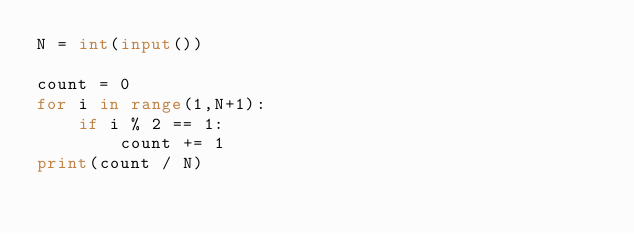Convert code to text. <code><loc_0><loc_0><loc_500><loc_500><_Python_>N = int(input())

count = 0
for i in range(1,N+1):
    if i % 2 == 1:
        count += 1
print(count / N)</code> 